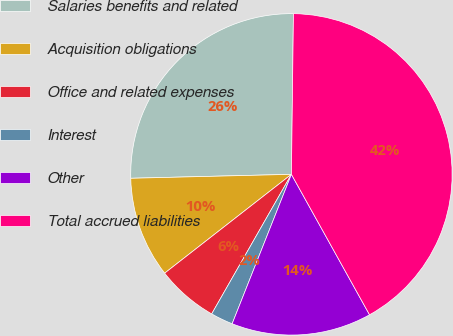Convert chart. <chart><loc_0><loc_0><loc_500><loc_500><pie_chart><fcel>Salaries benefits and related<fcel>Acquisition obligations<fcel>Office and related expenses<fcel>Interest<fcel>Other<fcel>Total accrued liabilities<nl><fcel>25.59%<fcel>10.15%<fcel>6.2%<fcel>2.25%<fcel>14.09%<fcel>41.72%<nl></chart> 